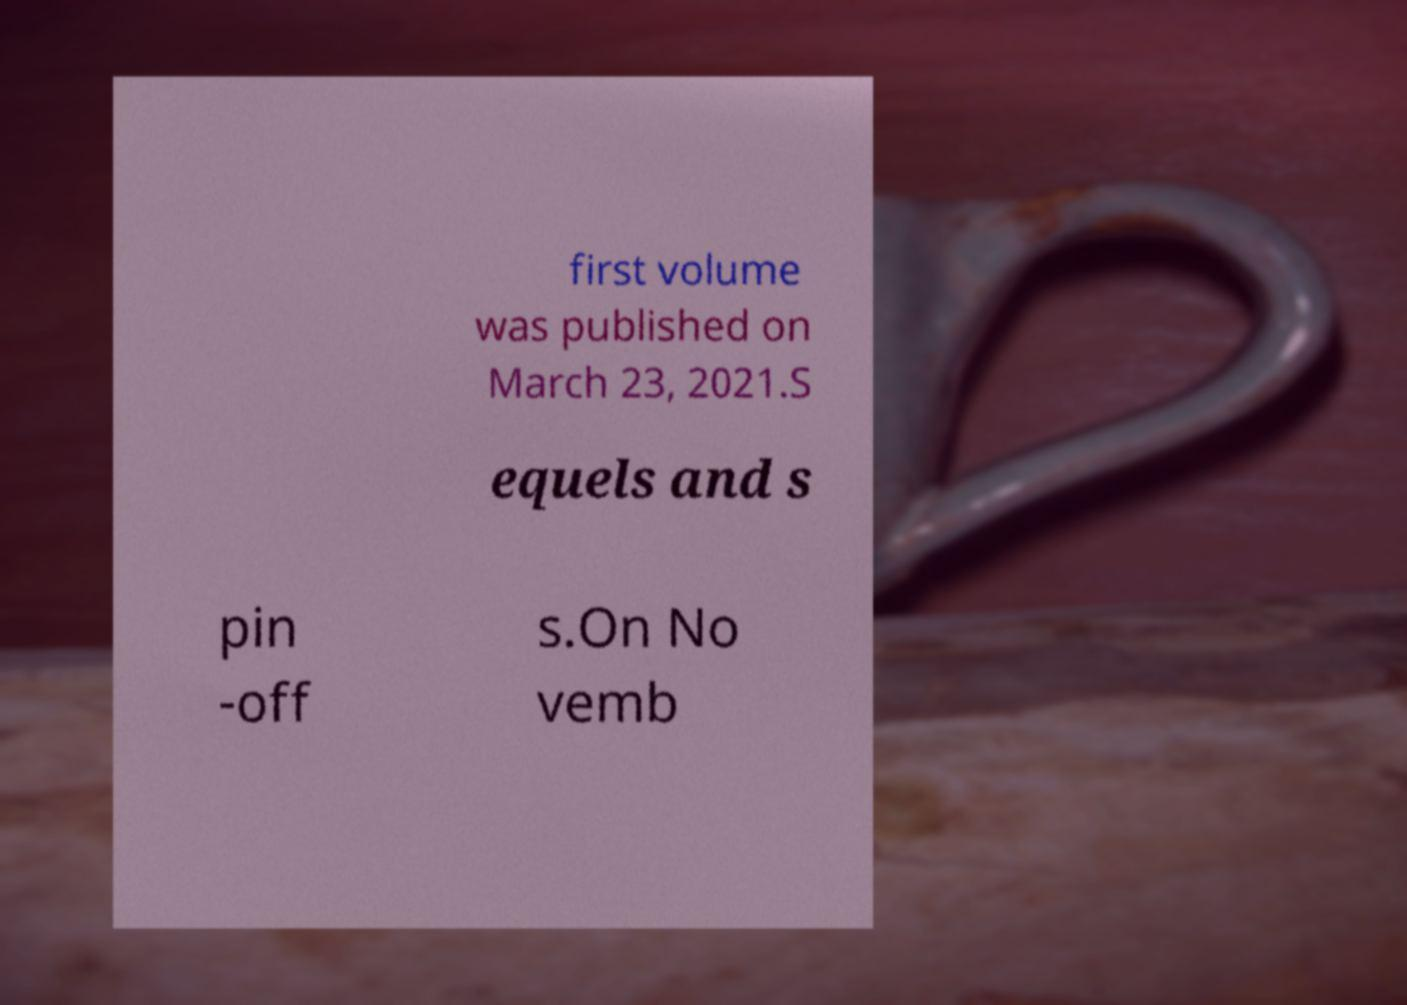For documentation purposes, I need the text within this image transcribed. Could you provide that? first volume was published on March 23, 2021.S equels and s pin -off s.On No vemb 